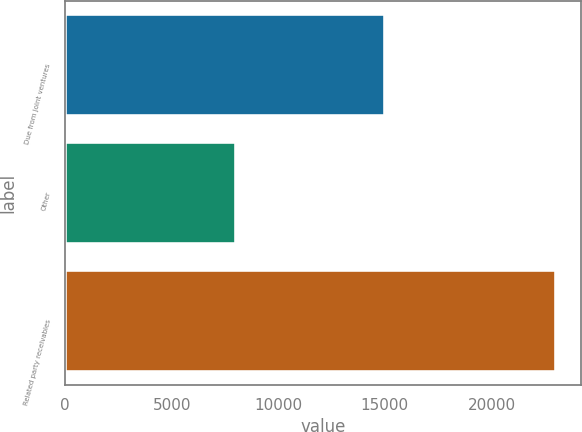<chart> <loc_0><loc_0><loc_500><loc_500><bar_chart><fcel>Due from joint ventures<fcel>Other<fcel>Related party receivables<nl><fcel>15025<fcel>8014<fcel>23039<nl></chart> 